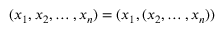<formula> <loc_0><loc_0><loc_500><loc_500>( x _ { 1 } , x _ { 2 } , \dots , x _ { n } ) = ( x _ { 1 } , ( x _ { 2 } , \dots , x _ { n } ) )</formula> 